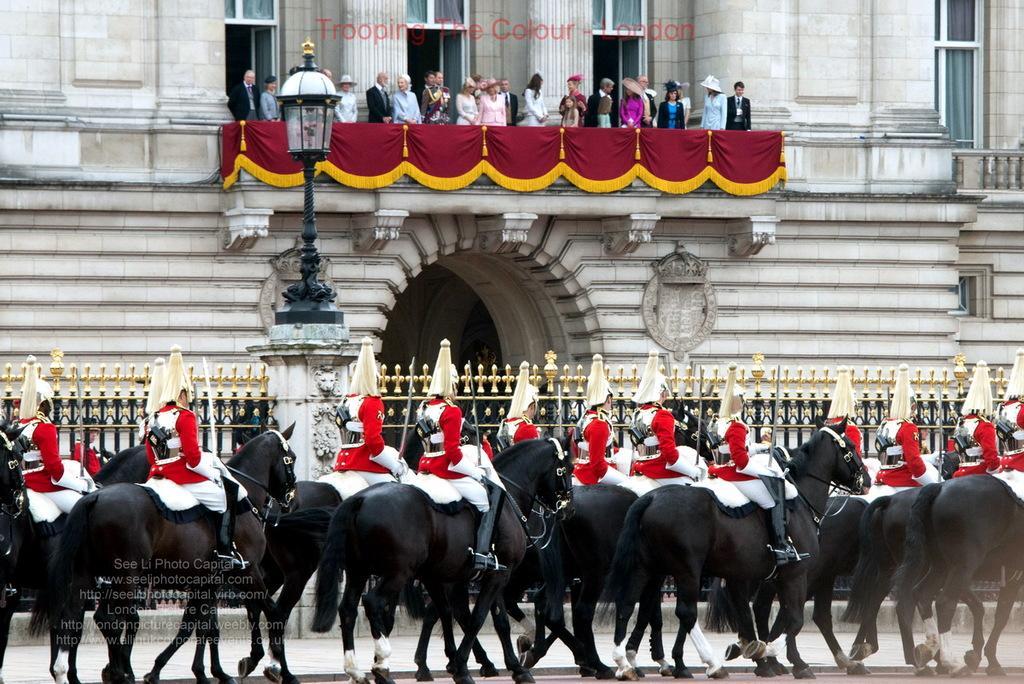Please provide a concise description of this image. To the bottom of the image there are many black horses standing. And on the horses there are men with white and red color uniform are sitting. Behind them there is a fencing and a pillar with a lamp pole. In the background there is a building with brick wall, pillar, window and a balcony with red and yellow cloth. And few people are standing in the balcony. 